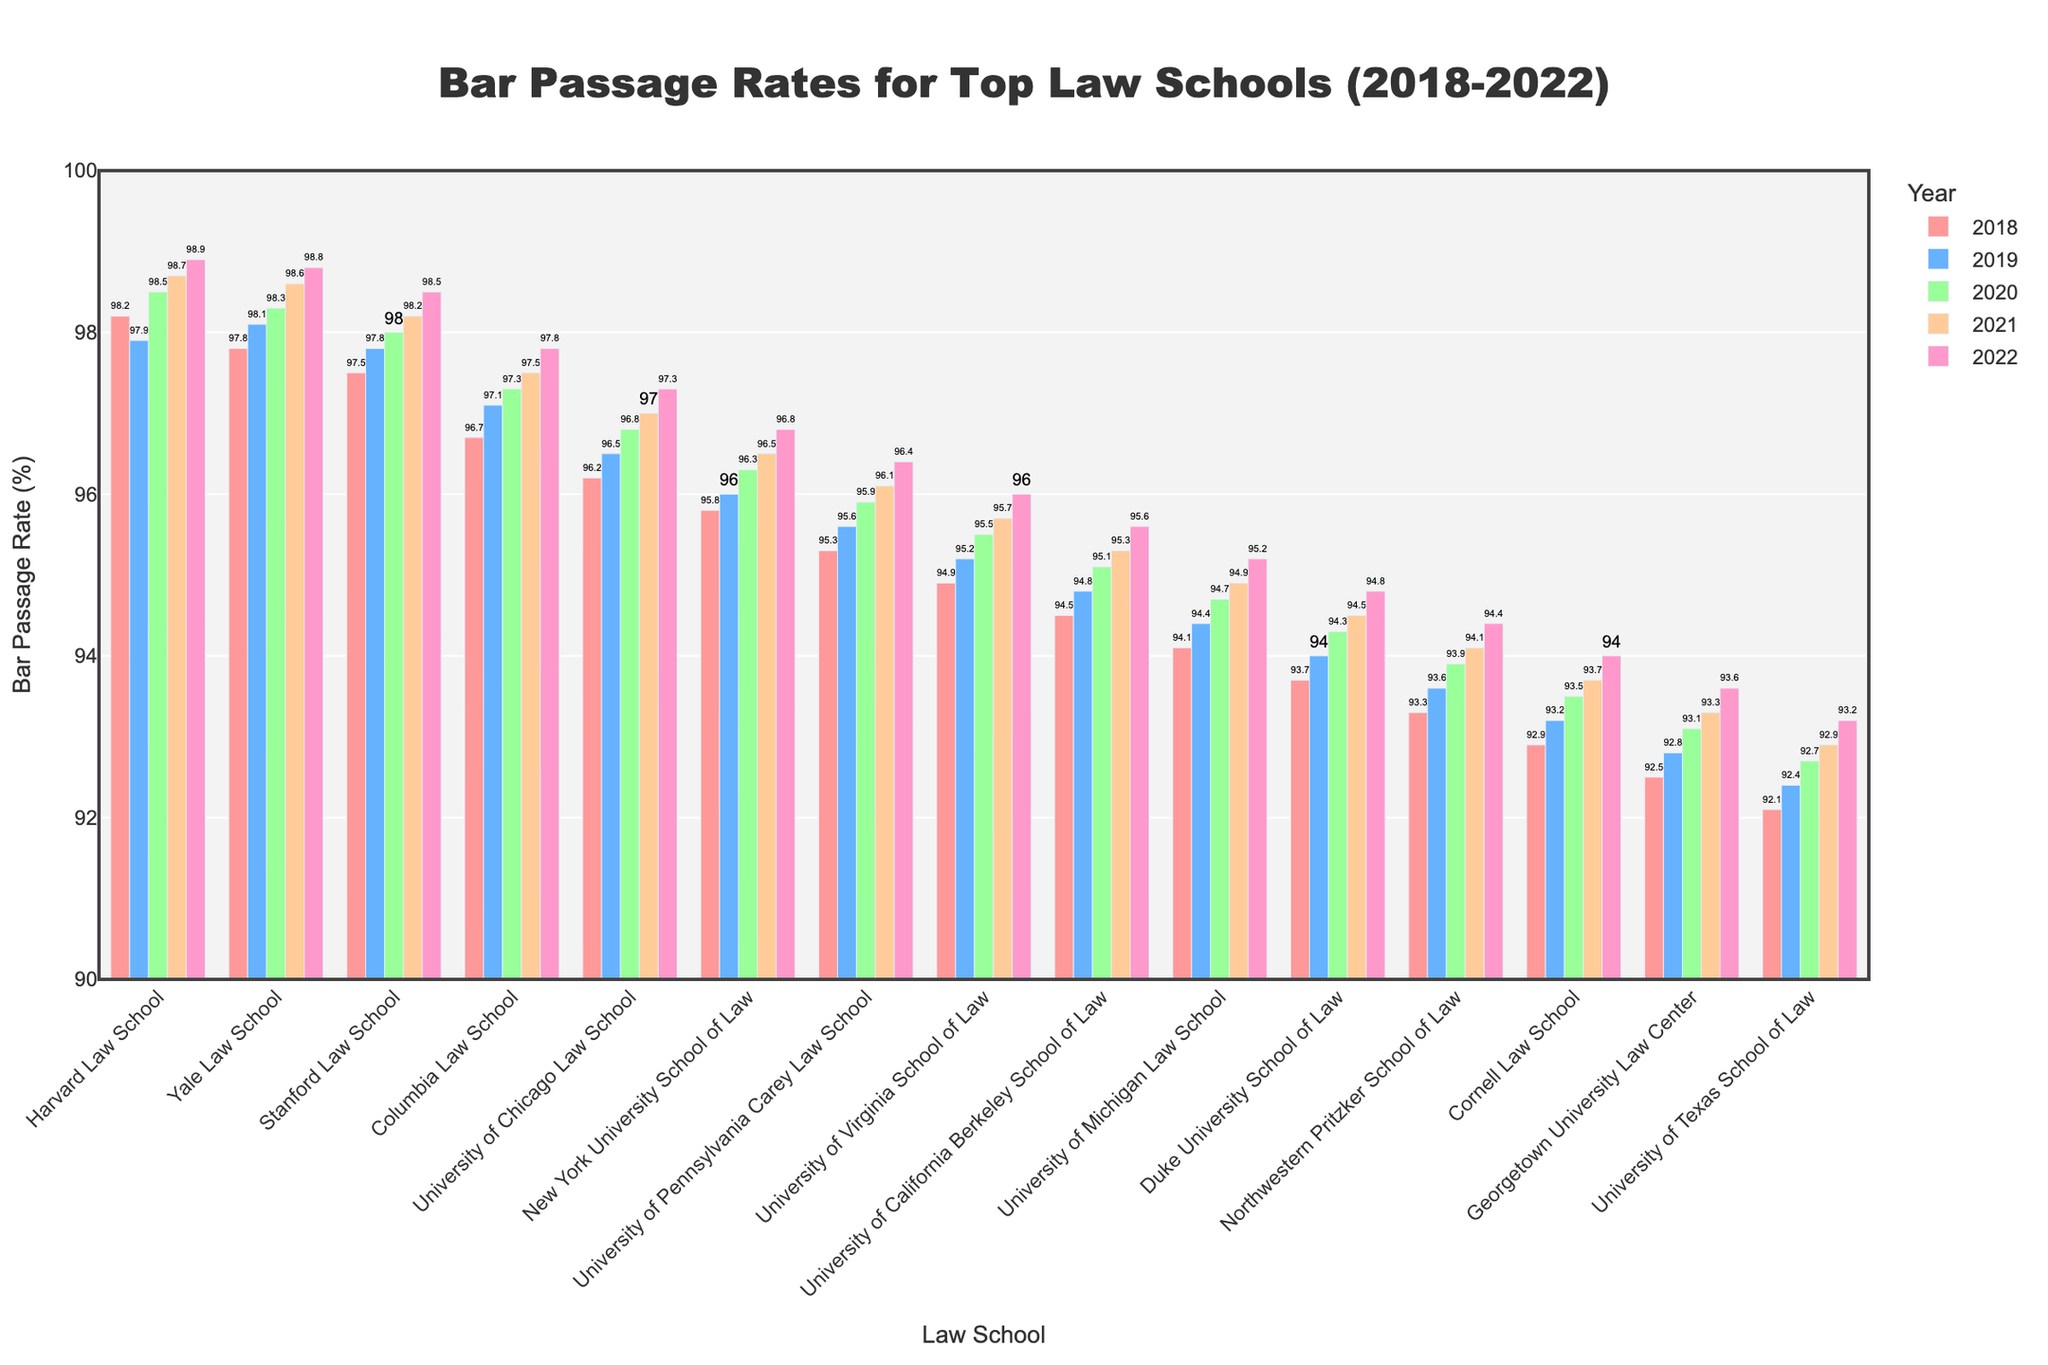What's the range of bar passage rates for Harvard Law School from 2018 to 2022? To find the range, subtract the minimum rate from the maximum rate. The rates are 98.2, 97.9, 98.5, 98.7, and 98.9. The maximum is 98.9 and the minimum is 97.9, so the range is 98.9 - 97.9 = 1.0
Answer: 1.0 Which law school had the highest bar passage rate in 2022? Look at the bars labeled "2022" and find the one with the tallest height. Harvard Law School has the tallest bar in 2022 with a 98.9% rate.
Answer: Harvard Law School Which law school showed the greatest improvement in bar passage rates from 2018 to 2022? Calculate the difference between 2022 and 2018 rates for each school. Harvard Law School: 98.9-98.2=0.7, Yale Law School: 98.8-97.8=1.0, etc. University of Virginia School of Law showed the greatest improvement with 96.0-94.9=1.1.
Answer: University of Virginia School of Law How many schools had a bar passage rate above 98% in 2021? Look at the bars labeled "2021" and count the ones with heights higher than 98%. Harvard, Yale, and Stanford all had rates above 98% in 2021.
Answer: 3 What's the average bar passage rate for Yale Law School over the five years? Sum the rates for Yale from 2018 to 2022 and divide by 5. (97.8 + 98.1 + 98.3 + 98.6 + 98.8)/5 = 98.32
Answer: 98.32 Which two law schools had the closest bar passage rates in 2020? Compare the heights of the bars labeled "2020" to find the smallest difference. Yale Law School (98.3) and Stanford Law School (98.0) had a difference of 0.3, which is the smallest.
Answer: Yale Law School and Stanford Law School By what percent did Columbia Law School's bar passage rate increase between 2018 and 2022? Calculate the percent increase by the formula: [(New Rate - Old Rate) / Old Rate] * 100. For Columbia, (97.8 - 96.7)/96.7 * 100 ≈ 1.14%.
Answer: 1.14% Was there any year that all schools achieved at least a 95% bar passage rate? Look at each year's bars and check if the lowest bar is 95% or higher. For instance, in 2022, all bars are above 95% while in other years, at least one school is below 95%.
Answer: 2022 Which school had the lowest improvement in their bar passage rate from 2018 to 2022? Calculate the difference between 2022 and 2018 rates for each law school. The lowest difference is for Northwestern Pritzker School of Law: 94.4-93.3=1.1.
Answer: Northwestern Pritzker School of Law Does the data suggest a general trend in bar passage rates for top law schools? Observe the heights of the bars for each school over five years. Generally, the bar passage rates for all schools show an upward trend from 2018 to 2022.
Answer: Upward trend 